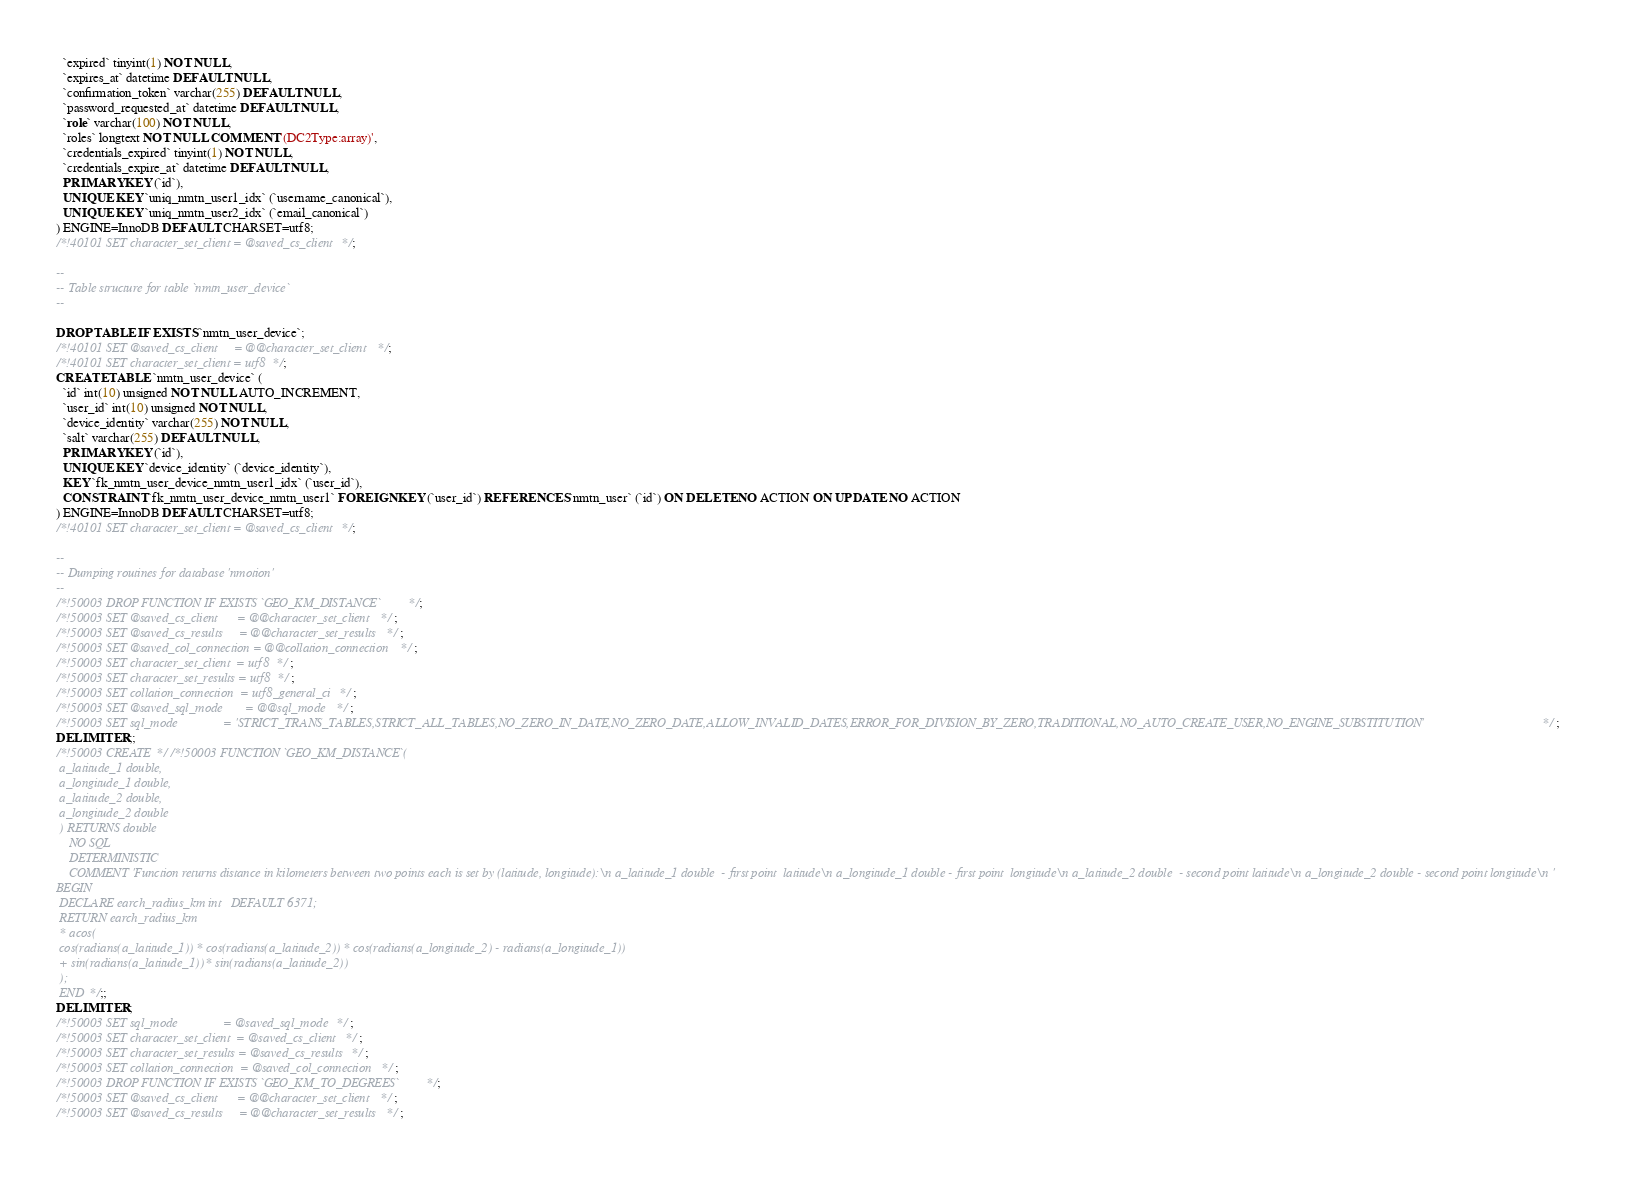Convert code to text. <code><loc_0><loc_0><loc_500><loc_500><_SQL_>  `expired` tinyint(1) NOT NULL,
  `expires_at` datetime DEFAULT NULL,
  `confirmation_token` varchar(255) DEFAULT NULL,
  `password_requested_at` datetime DEFAULT NULL,
  `role` varchar(100) NOT NULL,
  `roles` longtext NOT NULL COMMENT '(DC2Type:array)',
  `credentials_expired` tinyint(1) NOT NULL,
  `credentials_expire_at` datetime DEFAULT NULL,
  PRIMARY KEY (`id`),
  UNIQUE KEY `uniq_nmtn_user1_idx` (`username_canonical`),
  UNIQUE KEY `uniq_nmtn_user2_idx` (`email_canonical`)
) ENGINE=InnoDB DEFAULT CHARSET=utf8;
/*!40101 SET character_set_client = @saved_cs_client */;

--
-- Table structure for table `nmtn_user_device`
--

DROP TABLE IF EXISTS `nmtn_user_device`;
/*!40101 SET @saved_cs_client     = @@character_set_client */;
/*!40101 SET character_set_client = utf8 */;
CREATE TABLE `nmtn_user_device` (
  `id` int(10) unsigned NOT NULL AUTO_INCREMENT,
  `user_id` int(10) unsigned NOT NULL,
  `device_identity` varchar(255) NOT NULL,
  `salt` varchar(255) DEFAULT NULL,
  PRIMARY KEY (`id`),
  UNIQUE KEY `device_identity` (`device_identity`),
  KEY `fk_nmtn_user_device_nmtn_user1_idx` (`user_id`),
  CONSTRAINT `fk_nmtn_user_device_nmtn_user1` FOREIGN KEY (`user_id`) REFERENCES `nmtn_user` (`id`) ON DELETE NO ACTION ON UPDATE NO ACTION
) ENGINE=InnoDB DEFAULT CHARSET=utf8;
/*!40101 SET character_set_client = @saved_cs_client */;

--
-- Dumping routines for database 'nmotion'
--
/*!50003 DROP FUNCTION IF EXISTS `GEO_KM_DISTANCE` */;
/*!50003 SET @saved_cs_client      = @@character_set_client */ ;
/*!50003 SET @saved_cs_results     = @@character_set_results */ ;
/*!50003 SET @saved_col_connection = @@collation_connection */ ;
/*!50003 SET character_set_client  = utf8 */ ;
/*!50003 SET character_set_results = utf8 */ ;
/*!50003 SET collation_connection  = utf8_general_ci */ ;
/*!50003 SET @saved_sql_mode       = @@sql_mode */ ;
/*!50003 SET sql_mode              = 'STRICT_TRANS_TABLES,STRICT_ALL_TABLES,NO_ZERO_IN_DATE,NO_ZERO_DATE,ALLOW_INVALID_DATES,ERROR_FOR_DIVISION_BY_ZERO,TRADITIONAL,NO_AUTO_CREATE_USER,NO_ENGINE_SUBSTITUTION' */ ;
DELIMITER ;;
/*!50003 CREATE*/ /*!50003 FUNCTION `GEO_KM_DISTANCE`(
 a_latitude_1 double,
 a_longitude_1 double,
 a_latitude_2 double,
 a_longitude_2 double
 ) RETURNS double
    NO SQL
    DETERMINISTIC
    COMMENT 'Function returns distance in kilometers between two points each is set by (latitude, longitude):\n a_latitude_1 double  - first point  latitude\n a_longitude_1 double - first point  longitude\n a_latitude_2 double  - second point latitude\n a_longitude_2 double - second point longitude\n '
BEGIN
 DECLARE earch_radius_km int   DEFAULT 6371;
 RETURN earch_radius_km
 * acos(
 cos(radians(a_latitude_1)) * cos(radians(a_latitude_2)) * cos(radians(a_longitude_2) - radians(a_longitude_1))
 + sin(radians(a_latitude_1)) * sin(radians(a_latitude_2))
 );
 END */;;
DELIMITER ;
/*!50003 SET sql_mode              = @saved_sql_mode */ ;
/*!50003 SET character_set_client  = @saved_cs_client */ ;
/*!50003 SET character_set_results = @saved_cs_results */ ;
/*!50003 SET collation_connection  = @saved_col_connection */ ;
/*!50003 DROP FUNCTION IF EXISTS `GEO_KM_TO_DEGREES` */;
/*!50003 SET @saved_cs_client      = @@character_set_client */ ;
/*!50003 SET @saved_cs_results     = @@character_set_results */ ;</code> 